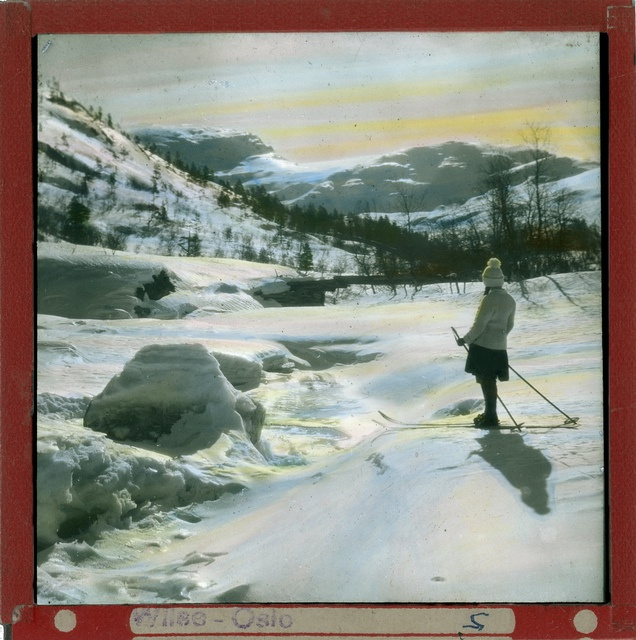Describe the objects in this image and their specific colors. I can see people in lightgray, teal, black, darkgreen, and darkgray tones and skis in lightgray, darkgray, beige, and black tones in this image. 